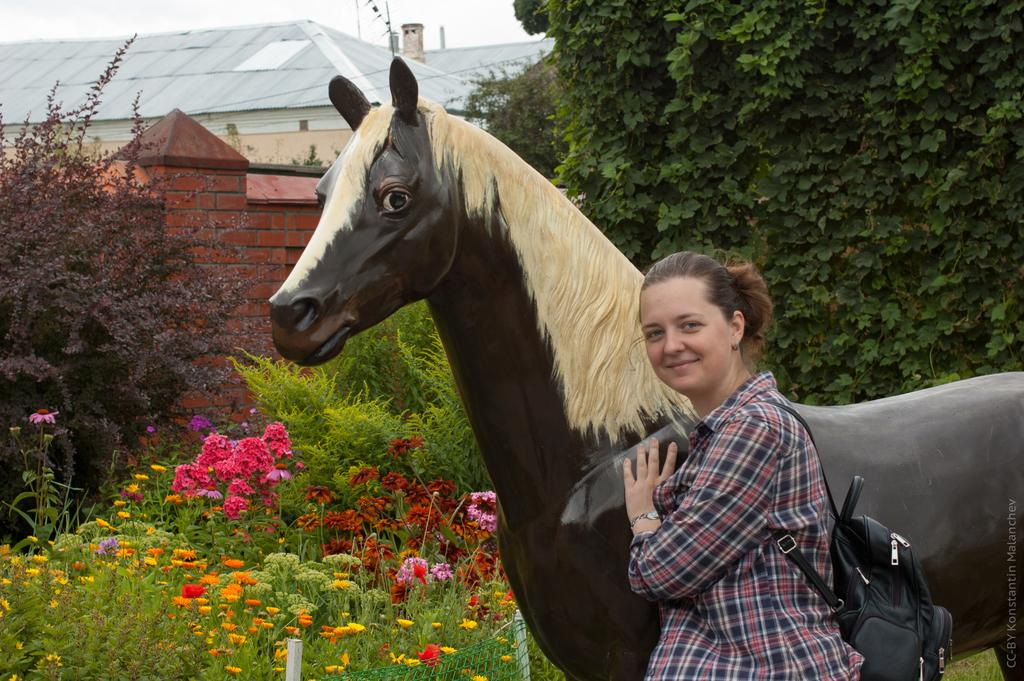Who is present in the image? There is a woman in the image. What is the woman standing near? The woman is standing near an artificial horse. What can be seen in the background of the image? There are flowers and trees in the background of the image. Can you see any mittens on the woman's hands in the image? There is no mention of mittens in the image, so it cannot be determined if the woman is wearing any. 